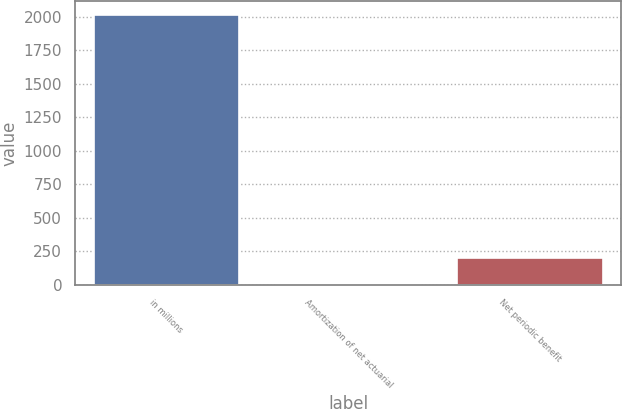<chart> <loc_0><loc_0><loc_500><loc_500><bar_chart><fcel>in millions<fcel>Amortization of net actuarial<fcel>Net periodic benefit<nl><fcel>2016<fcel>0.3<fcel>201.87<nl></chart> 